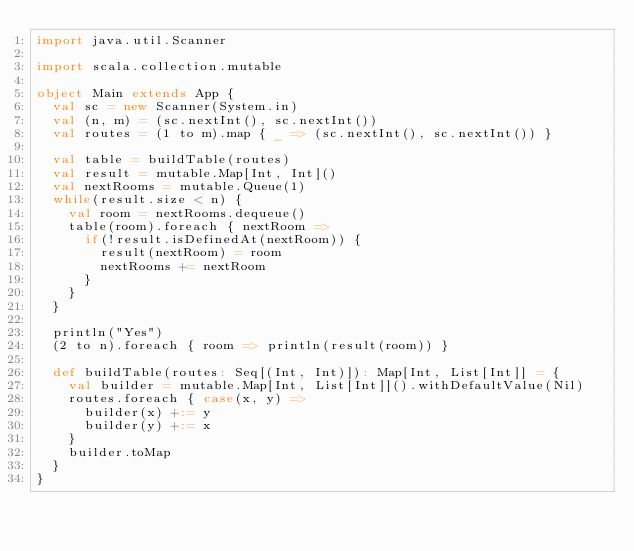<code> <loc_0><loc_0><loc_500><loc_500><_Scala_>import java.util.Scanner

import scala.collection.mutable

object Main extends App {
  val sc = new Scanner(System.in)
  val (n, m) = (sc.nextInt(), sc.nextInt())
  val routes = (1 to m).map { _ => (sc.nextInt(), sc.nextInt()) }

  val table = buildTable(routes)
  val result = mutable.Map[Int, Int]()
  val nextRooms = mutable.Queue(1)
  while(result.size < n) {
    val room = nextRooms.dequeue()
    table(room).foreach { nextRoom =>
      if(!result.isDefinedAt(nextRoom)) {
        result(nextRoom) = room
        nextRooms += nextRoom
      }
    }
  }

  println("Yes")
  (2 to n).foreach { room => println(result(room)) }

  def buildTable(routes: Seq[(Int, Int)]): Map[Int, List[Int]] = {
    val builder = mutable.Map[Int, List[Int]]().withDefaultValue(Nil)
    routes.foreach { case(x, y) =>
      builder(x) +:= y
      builder(y) +:= x
    }
    builder.toMap
  }
}
</code> 